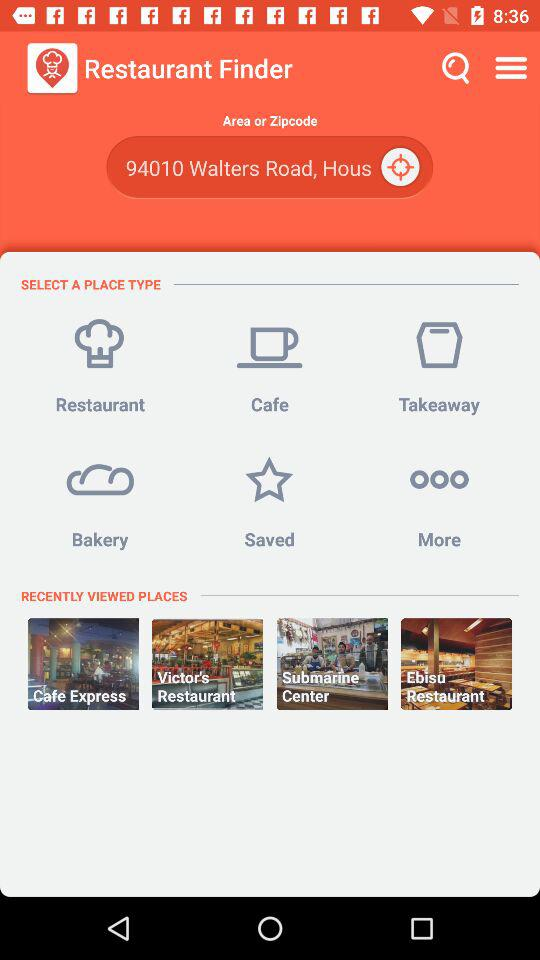How many place types are there?
Answer the question using a single word or phrase. 4 